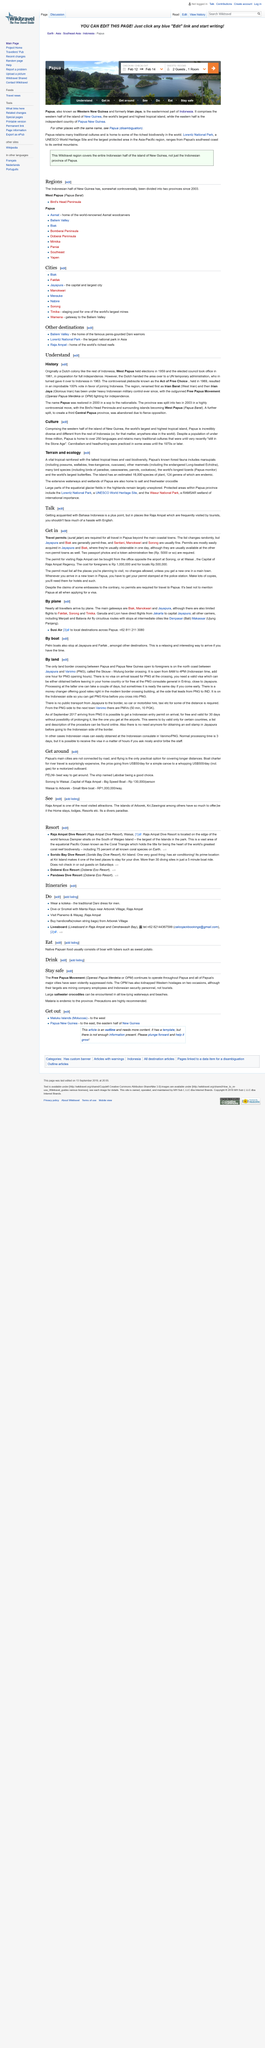Outline some significant characteristics in this image. The Dani warriors of Baliem Valley are renowned for their fearsome penis gourds, and their home is located in the Baliem Valley. Wikitravel covers the entire Indonesian half of the island of New Guinea, which includes the Indonesian province of Papua, as well as other parts of the island that are not part of the Indonesian territory. The Lorentz National Park spans from the southwest coast of Papua to its central mountains, encompassing a vast and diverse range of landscapes and ecosystems. New Guinea was divided into two provinces named Papua and West Papua. Pelni boats also stop at Jayapura and Farfak, in addition to other destinations. 